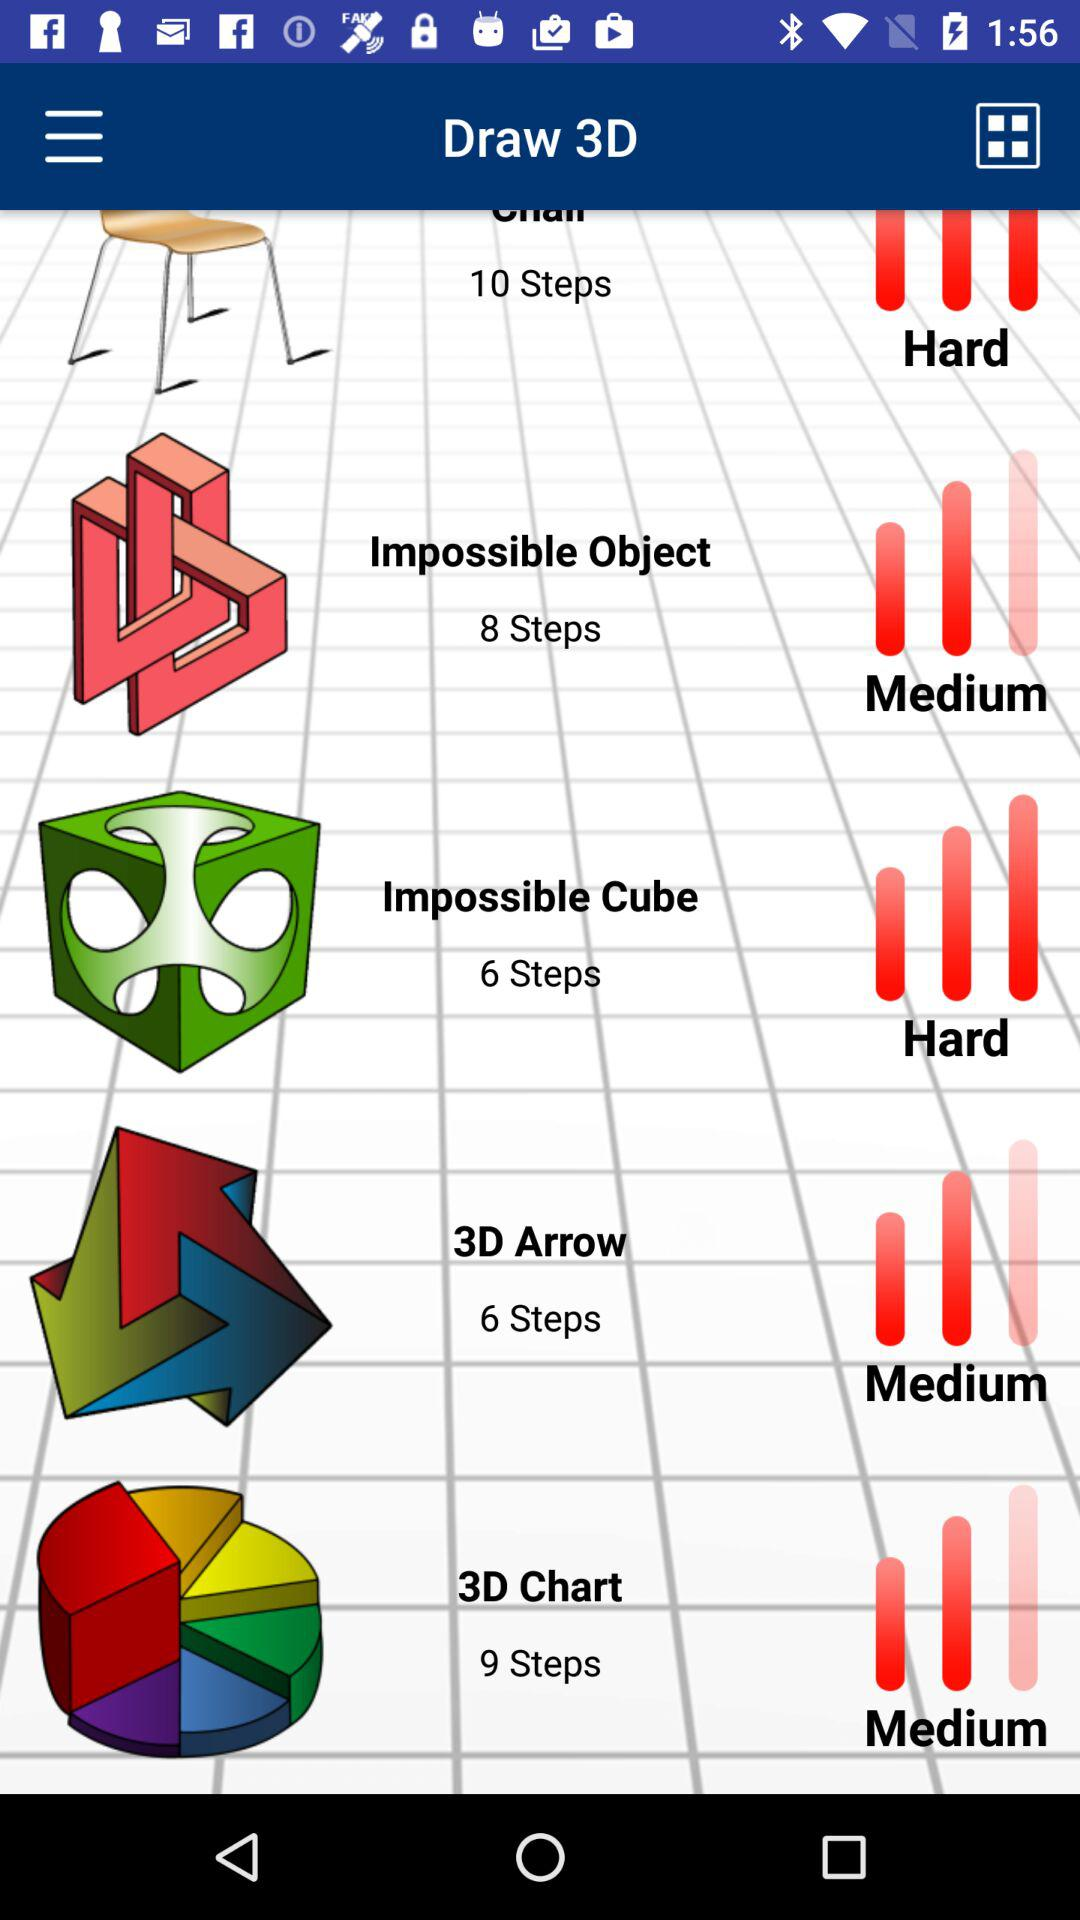How many steps are in the "3D arrow"? There are 6 steps in the "3D arrow". 